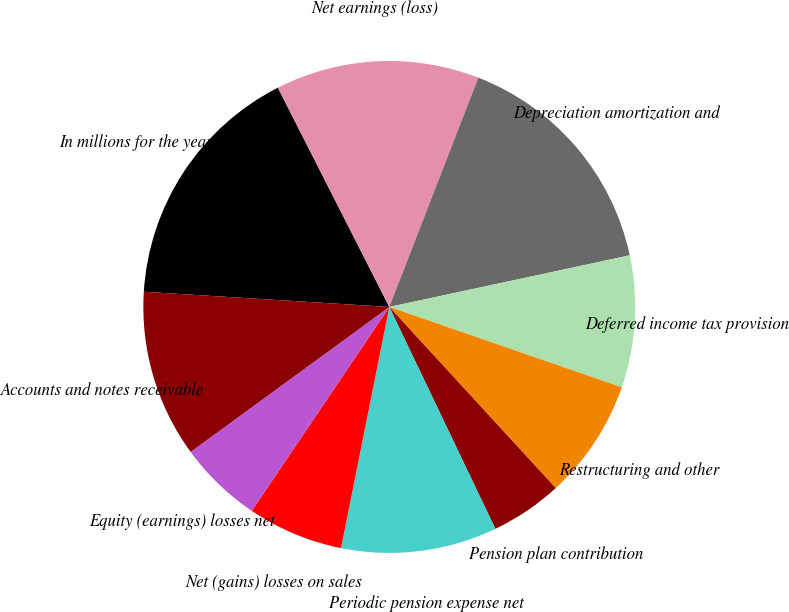Convert chart. <chart><loc_0><loc_0><loc_500><loc_500><pie_chart><fcel>In millions for the years<fcel>Net earnings (loss)<fcel>Depreciation amortization and<fcel>Deferred income tax provision<fcel>Restructuring and other<fcel>Pension plan contribution<fcel>Periodic pension expense net<fcel>Net (gains) losses on sales<fcel>Equity (earnings) losses net<fcel>Accounts and notes receivable<nl><fcel>16.53%<fcel>13.38%<fcel>15.74%<fcel>8.66%<fcel>7.88%<fcel>4.73%<fcel>10.24%<fcel>6.3%<fcel>5.52%<fcel>11.02%<nl></chart> 